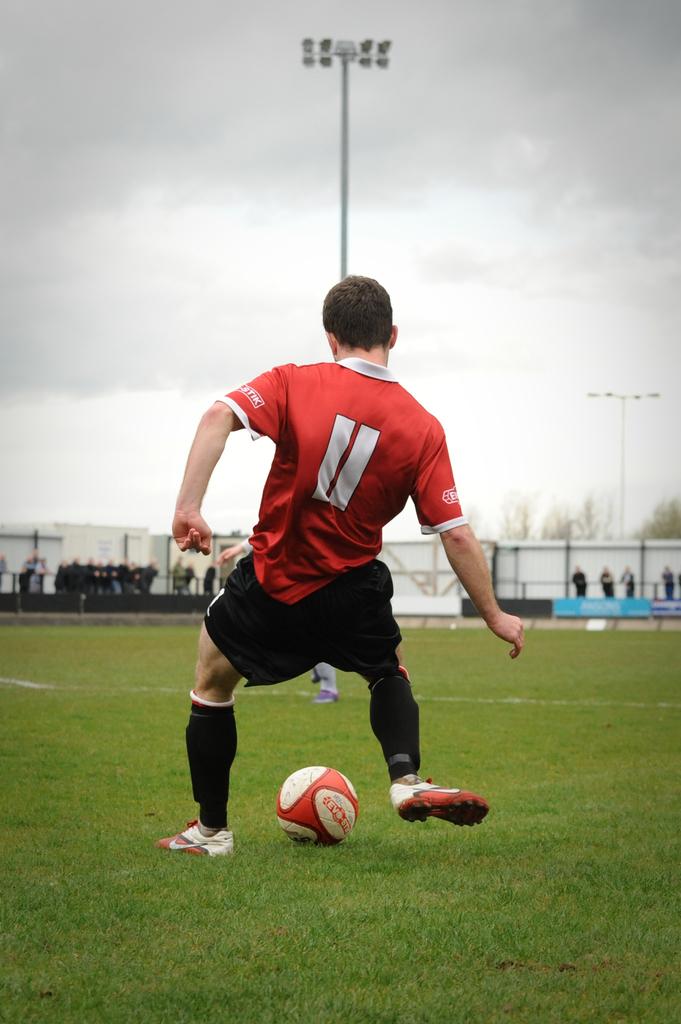What number is he?
Provide a succinct answer. 11. What 3 letters are on the left sleeve of the players shirt?
Keep it short and to the point. Tik. 